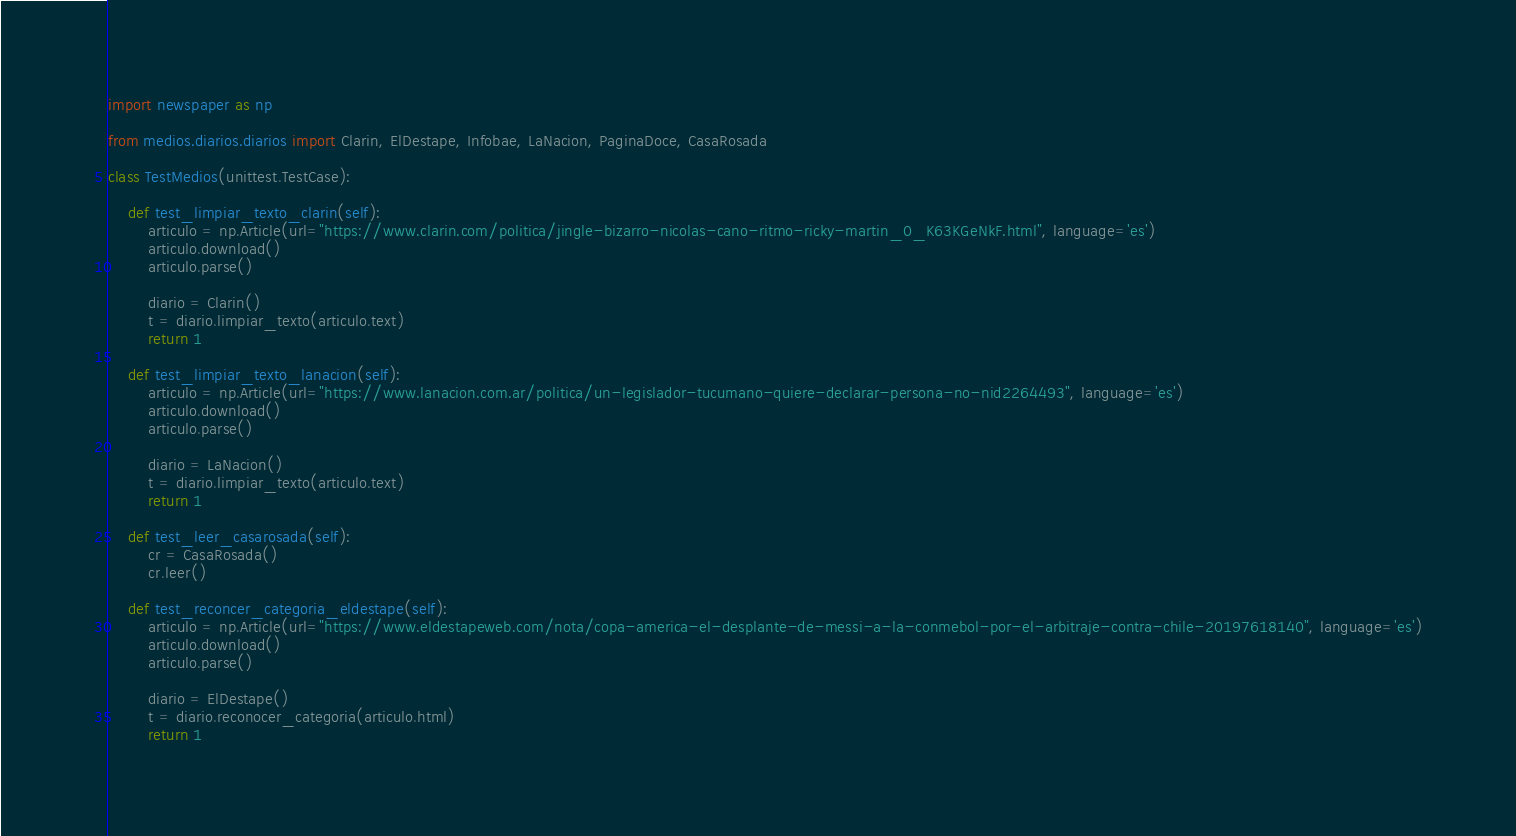Convert code to text. <code><loc_0><loc_0><loc_500><loc_500><_Python_>
import newspaper as np

from medios.diarios.diarios import Clarin, ElDestape, Infobae, LaNacion, PaginaDoce, CasaRosada

class TestMedios(unittest.TestCase):

    def test_limpiar_texto_clarin(self):
        articulo = np.Article(url="https://www.clarin.com/politica/jingle-bizarro-nicolas-cano-ritmo-ricky-martin_0_K63KGeNkF.html", language='es')
        articulo.download()
        articulo.parse()

        diario = Clarin()
        t = diario.limpiar_texto(articulo.text)
        return 1
    
    def test_limpiar_texto_lanacion(self):
        articulo = np.Article(url="https://www.lanacion.com.ar/politica/un-legislador-tucumano-quiere-declarar-persona-no-nid2264493", language='es')
        articulo.download()
        articulo.parse()

        diario = LaNacion()
        t = diario.limpiar_texto(articulo.text)
        return 1

    def test_leer_casarosada(self):
        cr = CasaRosada()
        cr.leer()
        
    def test_reconcer_categoria_eldestape(self):
        articulo = np.Article(url="https://www.eldestapeweb.com/nota/copa-america-el-desplante-de-messi-a-la-conmebol-por-el-arbitraje-contra-chile-20197618140", language='es')
        articulo.download()
        articulo.parse()

        diario = ElDestape()
        t = diario.reconocer_categoria(articulo.html)
        return 1

</code> 